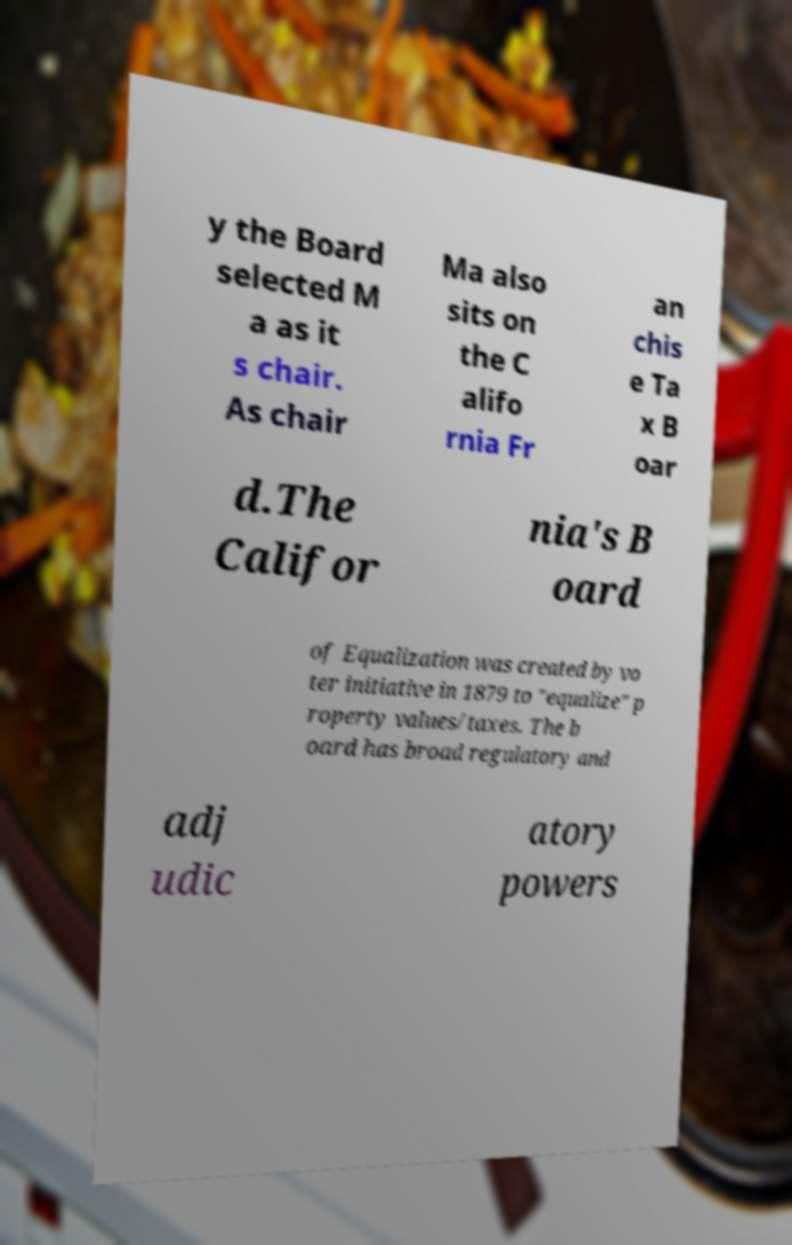There's text embedded in this image that I need extracted. Can you transcribe it verbatim? y the Board selected M a as it s chair. As chair Ma also sits on the C alifo rnia Fr an chis e Ta x B oar d.The Califor nia's B oard of Equalization was created by vo ter initiative in 1879 to "equalize" p roperty values/taxes. The b oard has broad regulatory and adj udic atory powers 